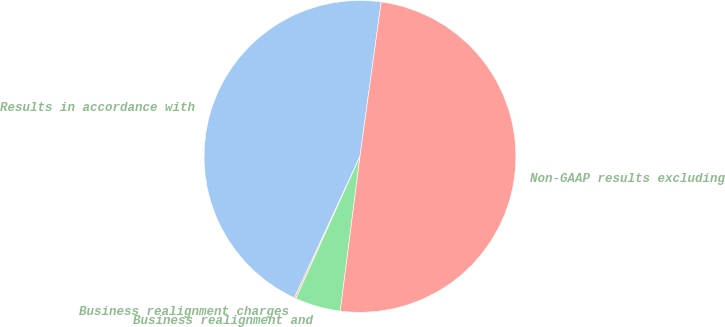<chart> <loc_0><loc_0><loc_500><loc_500><pie_chart><fcel>Results in accordance with<fcel>Business realignment charges<fcel>Business realignment and<fcel>Non-GAAP results excluding<nl><fcel>45.27%<fcel>0.16%<fcel>4.73%<fcel>49.84%<nl></chart> 